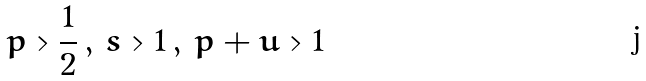<formula> <loc_0><loc_0><loc_500><loc_500>p > \frac { 1 } { 2 } \, , \, s > 1 \, , \, p + u > 1</formula> 